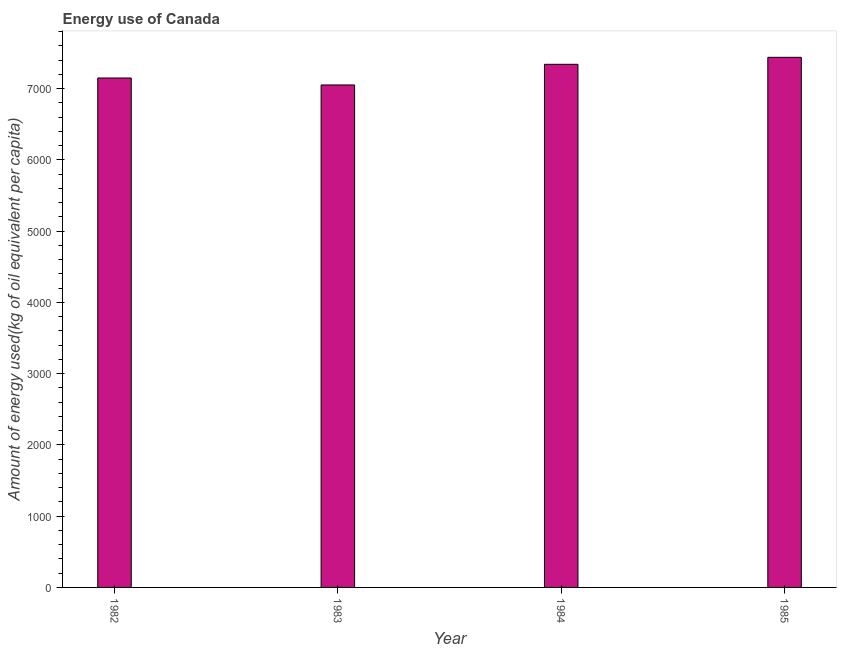Does the graph contain any zero values?
Give a very brief answer. No. Does the graph contain grids?
Make the answer very short. No. What is the title of the graph?
Keep it short and to the point. Energy use of Canada. What is the label or title of the X-axis?
Keep it short and to the point. Year. What is the label or title of the Y-axis?
Make the answer very short. Amount of energy used(kg of oil equivalent per capita). What is the amount of energy used in 1985?
Provide a short and direct response. 7439.34. Across all years, what is the maximum amount of energy used?
Provide a short and direct response. 7439.34. Across all years, what is the minimum amount of energy used?
Keep it short and to the point. 7051.63. What is the sum of the amount of energy used?
Ensure brevity in your answer.  2.90e+04. What is the difference between the amount of energy used in 1983 and 1985?
Offer a very short reply. -387.71. What is the average amount of energy used per year?
Ensure brevity in your answer.  7245.46. What is the median amount of energy used?
Give a very brief answer. 7245.43. Do a majority of the years between 1984 and 1983 (inclusive) have amount of energy used greater than 2800 kg?
Your answer should be very brief. No. What is the ratio of the amount of energy used in 1982 to that in 1983?
Provide a short and direct response. 1.01. Is the amount of energy used in 1983 less than that in 1985?
Ensure brevity in your answer.  Yes. Is the difference between the amount of energy used in 1982 and 1984 greater than the difference between any two years?
Offer a terse response. No. What is the difference between the highest and the second highest amount of energy used?
Offer a terse response. 97.82. Is the sum of the amount of energy used in 1982 and 1983 greater than the maximum amount of energy used across all years?
Your answer should be very brief. Yes. What is the difference between the highest and the lowest amount of energy used?
Provide a succinct answer. 387.71. In how many years, is the amount of energy used greater than the average amount of energy used taken over all years?
Make the answer very short. 2. Are the values on the major ticks of Y-axis written in scientific E-notation?
Offer a terse response. No. What is the Amount of energy used(kg of oil equivalent per capita) in 1982?
Ensure brevity in your answer.  7149.34. What is the Amount of energy used(kg of oil equivalent per capita) of 1983?
Make the answer very short. 7051.63. What is the Amount of energy used(kg of oil equivalent per capita) of 1984?
Give a very brief answer. 7341.52. What is the Amount of energy used(kg of oil equivalent per capita) of 1985?
Provide a short and direct response. 7439.34. What is the difference between the Amount of energy used(kg of oil equivalent per capita) in 1982 and 1983?
Give a very brief answer. 97.71. What is the difference between the Amount of energy used(kg of oil equivalent per capita) in 1982 and 1984?
Provide a succinct answer. -192.18. What is the difference between the Amount of energy used(kg of oil equivalent per capita) in 1982 and 1985?
Keep it short and to the point. -290. What is the difference between the Amount of energy used(kg of oil equivalent per capita) in 1983 and 1984?
Provide a succinct answer. -289.89. What is the difference between the Amount of energy used(kg of oil equivalent per capita) in 1983 and 1985?
Ensure brevity in your answer.  -387.71. What is the difference between the Amount of energy used(kg of oil equivalent per capita) in 1984 and 1985?
Provide a succinct answer. -97.82. What is the ratio of the Amount of energy used(kg of oil equivalent per capita) in 1982 to that in 1984?
Ensure brevity in your answer.  0.97. What is the ratio of the Amount of energy used(kg of oil equivalent per capita) in 1983 to that in 1985?
Make the answer very short. 0.95. What is the ratio of the Amount of energy used(kg of oil equivalent per capita) in 1984 to that in 1985?
Offer a terse response. 0.99. 